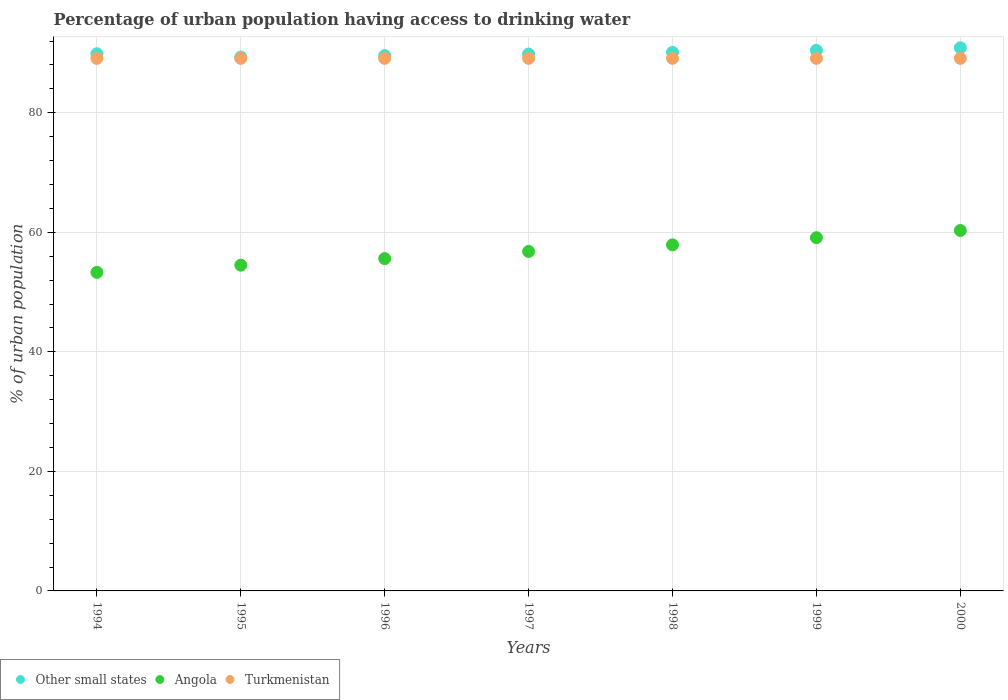Is the number of dotlines equal to the number of legend labels?
Give a very brief answer. Yes. What is the percentage of urban population having access to drinking water in Angola in 1998?
Keep it short and to the point. 57.9. Across all years, what is the maximum percentage of urban population having access to drinking water in Turkmenistan?
Offer a very short reply. 89.1. Across all years, what is the minimum percentage of urban population having access to drinking water in Other small states?
Provide a succinct answer. 89.31. In which year was the percentage of urban population having access to drinking water in Angola minimum?
Offer a very short reply. 1994. What is the total percentage of urban population having access to drinking water in Turkmenistan in the graph?
Make the answer very short. 623.7. What is the difference between the percentage of urban population having access to drinking water in Other small states in 1995 and that in 2000?
Offer a very short reply. -1.55. What is the difference between the percentage of urban population having access to drinking water in Angola in 1998 and the percentage of urban population having access to drinking water in Turkmenistan in 1996?
Give a very brief answer. -31.2. What is the average percentage of urban population having access to drinking water in Other small states per year?
Your response must be concise. 90. In the year 1998, what is the difference between the percentage of urban population having access to drinking water in Other small states and percentage of urban population having access to drinking water in Angola?
Give a very brief answer. 32.21. In how many years, is the percentage of urban population having access to drinking water in Turkmenistan greater than 60 %?
Your answer should be compact. 7. Is the percentage of urban population having access to drinking water in Angola in 1998 less than that in 2000?
Keep it short and to the point. Yes. Is the difference between the percentage of urban population having access to drinking water in Other small states in 1996 and 1998 greater than the difference between the percentage of urban population having access to drinking water in Angola in 1996 and 1998?
Your answer should be very brief. Yes. In how many years, is the percentage of urban population having access to drinking water in Angola greater than the average percentage of urban population having access to drinking water in Angola taken over all years?
Make the answer very short. 4. Is it the case that in every year, the sum of the percentage of urban population having access to drinking water in Other small states and percentage of urban population having access to drinking water in Turkmenistan  is greater than the percentage of urban population having access to drinking water in Angola?
Your response must be concise. Yes. Does the percentage of urban population having access to drinking water in Other small states monotonically increase over the years?
Keep it short and to the point. No. Is the percentage of urban population having access to drinking water in Angola strictly greater than the percentage of urban population having access to drinking water in Turkmenistan over the years?
Keep it short and to the point. No. How many years are there in the graph?
Ensure brevity in your answer.  7. Does the graph contain any zero values?
Your answer should be very brief. No. Does the graph contain grids?
Ensure brevity in your answer.  Yes. How many legend labels are there?
Keep it short and to the point. 3. How are the legend labels stacked?
Offer a terse response. Horizontal. What is the title of the graph?
Give a very brief answer. Percentage of urban population having access to drinking water. Does "Low & middle income" appear as one of the legend labels in the graph?
Your response must be concise. No. What is the label or title of the X-axis?
Provide a succinct answer. Years. What is the label or title of the Y-axis?
Your answer should be very brief. % of urban population. What is the % of urban population of Other small states in 1994?
Ensure brevity in your answer.  89.87. What is the % of urban population in Angola in 1994?
Your answer should be compact. 53.3. What is the % of urban population in Turkmenistan in 1994?
Make the answer very short. 89.1. What is the % of urban population in Other small states in 1995?
Keep it short and to the point. 89.31. What is the % of urban population in Angola in 1995?
Give a very brief answer. 54.5. What is the % of urban population in Turkmenistan in 1995?
Ensure brevity in your answer.  89.1. What is the % of urban population of Other small states in 1996?
Keep it short and to the point. 89.56. What is the % of urban population of Angola in 1996?
Ensure brevity in your answer.  55.6. What is the % of urban population of Turkmenistan in 1996?
Provide a succinct answer. 89.1. What is the % of urban population of Other small states in 1997?
Keep it short and to the point. 89.83. What is the % of urban population in Angola in 1997?
Keep it short and to the point. 56.8. What is the % of urban population in Turkmenistan in 1997?
Ensure brevity in your answer.  89.1. What is the % of urban population in Other small states in 1998?
Offer a very short reply. 90.11. What is the % of urban population of Angola in 1998?
Offer a terse response. 57.9. What is the % of urban population in Turkmenistan in 1998?
Provide a short and direct response. 89.1. What is the % of urban population in Other small states in 1999?
Make the answer very short. 90.45. What is the % of urban population in Angola in 1999?
Your answer should be very brief. 59.1. What is the % of urban population in Turkmenistan in 1999?
Offer a terse response. 89.1. What is the % of urban population of Other small states in 2000?
Your response must be concise. 90.87. What is the % of urban population in Angola in 2000?
Provide a short and direct response. 60.3. What is the % of urban population of Turkmenistan in 2000?
Ensure brevity in your answer.  89.1. Across all years, what is the maximum % of urban population in Other small states?
Provide a succinct answer. 90.87. Across all years, what is the maximum % of urban population of Angola?
Offer a very short reply. 60.3. Across all years, what is the maximum % of urban population of Turkmenistan?
Make the answer very short. 89.1. Across all years, what is the minimum % of urban population in Other small states?
Your answer should be very brief. 89.31. Across all years, what is the minimum % of urban population of Angola?
Your response must be concise. 53.3. Across all years, what is the minimum % of urban population of Turkmenistan?
Keep it short and to the point. 89.1. What is the total % of urban population in Other small states in the graph?
Give a very brief answer. 630. What is the total % of urban population of Angola in the graph?
Your answer should be very brief. 397.5. What is the total % of urban population in Turkmenistan in the graph?
Provide a succinct answer. 623.7. What is the difference between the % of urban population of Other small states in 1994 and that in 1995?
Offer a terse response. 0.56. What is the difference between the % of urban population in Turkmenistan in 1994 and that in 1995?
Keep it short and to the point. 0. What is the difference between the % of urban population of Other small states in 1994 and that in 1996?
Offer a very short reply. 0.31. What is the difference between the % of urban population of Angola in 1994 and that in 1996?
Ensure brevity in your answer.  -2.3. What is the difference between the % of urban population in Other small states in 1994 and that in 1997?
Offer a very short reply. 0.04. What is the difference between the % of urban population of Other small states in 1994 and that in 1998?
Provide a succinct answer. -0.24. What is the difference between the % of urban population in Turkmenistan in 1994 and that in 1998?
Provide a succinct answer. 0. What is the difference between the % of urban population of Other small states in 1994 and that in 1999?
Make the answer very short. -0.57. What is the difference between the % of urban population in Angola in 1994 and that in 1999?
Provide a succinct answer. -5.8. What is the difference between the % of urban population of Other small states in 1994 and that in 2000?
Give a very brief answer. -0.99. What is the difference between the % of urban population of Angola in 1994 and that in 2000?
Your answer should be very brief. -7. What is the difference between the % of urban population in Other small states in 1995 and that in 1996?
Your response must be concise. -0.25. What is the difference between the % of urban population of Turkmenistan in 1995 and that in 1996?
Offer a very short reply. 0. What is the difference between the % of urban population in Other small states in 1995 and that in 1997?
Offer a terse response. -0.51. What is the difference between the % of urban population in Turkmenistan in 1995 and that in 1997?
Ensure brevity in your answer.  0. What is the difference between the % of urban population in Other small states in 1995 and that in 1998?
Offer a terse response. -0.8. What is the difference between the % of urban population in Turkmenistan in 1995 and that in 1998?
Keep it short and to the point. 0. What is the difference between the % of urban population of Other small states in 1995 and that in 1999?
Offer a terse response. -1.13. What is the difference between the % of urban population of Other small states in 1995 and that in 2000?
Offer a terse response. -1.55. What is the difference between the % of urban population in Angola in 1995 and that in 2000?
Ensure brevity in your answer.  -5.8. What is the difference between the % of urban population in Other small states in 1996 and that in 1997?
Your answer should be compact. -0.27. What is the difference between the % of urban population in Angola in 1996 and that in 1997?
Your answer should be compact. -1.2. What is the difference between the % of urban population in Other small states in 1996 and that in 1998?
Provide a short and direct response. -0.55. What is the difference between the % of urban population in Turkmenistan in 1996 and that in 1998?
Your response must be concise. 0. What is the difference between the % of urban population of Other small states in 1996 and that in 1999?
Give a very brief answer. -0.89. What is the difference between the % of urban population of Other small states in 1996 and that in 2000?
Give a very brief answer. -1.31. What is the difference between the % of urban population in Angola in 1996 and that in 2000?
Ensure brevity in your answer.  -4.7. What is the difference between the % of urban population in Other small states in 1997 and that in 1998?
Provide a succinct answer. -0.28. What is the difference between the % of urban population of Other small states in 1997 and that in 1999?
Give a very brief answer. -0.62. What is the difference between the % of urban population of Angola in 1997 and that in 1999?
Keep it short and to the point. -2.3. What is the difference between the % of urban population in Other small states in 1997 and that in 2000?
Ensure brevity in your answer.  -1.04. What is the difference between the % of urban population in Other small states in 1998 and that in 1999?
Make the answer very short. -0.33. What is the difference between the % of urban population in Angola in 1998 and that in 1999?
Keep it short and to the point. -1.2. What is the difference between the % of urban population of Other small states in 1998 and that in 2000?
Provide a succinct answer. -0.75. What is the difference between the % of urban population in Turkmenistan in 1998 and that in 2000?
Your answer should be very brief. 0. What is the difference between the % of urban population of Other small states in 1999 and that in 2000?
Ensure brevity in your answer.  -0.42. What is the difference between the % of urban population of Turkmenistan in 1999 and that in 2000?
Keep it short and to the point. 0. What is the difference between the % of urban population in Other small states in 1994 and the % of urban population in Angola in 1995?
Give a very brief answer. 35.37. What is the difference between the % of urban population in Other small states in 1994 and the % of urban population in Turkmenistan in 1995?
Give a very brief answer. 0.77. What is the difference between the % of urban population of Angola in 1994 and the % of urban population of Turkmenistan in 1995?
Give a very brief answer. -35.8. What is the difference between the % of urban population of Other small states in 1994 and the % of urban population of Angola in 1996?
Your answer should be compact. 34.27. What is the difference between the % of urban population of Other small states in 1994 and the % of urban population of Turkmenistan in 1996?
Provide a short and direct response. 0.77. What is the difference between the % of urban population in Angola in 1994 and the % of urban population in Turkmenistan in 1996?
Offer a terse response. -35.8. What is the difference between the % of urban population in Other small states in 1994 and the % of urban population in Angola in 1997?
Provide a succinct answer. 33.07. What is the difference between the % of urban population in Other small states in 1994 and the % of urban population in Turkmenistan in 1997?
Your answer should be very brief. 0.77. What is the difference between the % of urban population of Angola in 1994 and the % of urban population of Turkmenistan in 1997?
Keep it short and to the point. -35.8. What is the difference between the % of urban population in Other small states in 1994 and the % of urban population in Angola in 1998?
Make the answer very short. 31.97. What is the difference between the % of urban population of Other small states in 1994 and the % of urban population of Turkmenistan in 1998?
Make the answer very short. 0.77. What is the difference between the % of urban population in Angola in 1994 and the % of urban population in Turkmenistan in 1998?
Ensure brevity in your answer.  -35.8. What is the difference between the % of urban population of Other small states in 1994 and the % of urban population of Angola in 1999?
Give a very brief answer. 30.77. What is the difference between the % of urban population in Other small states in 1994 and the % of urban population in Turkmenistan in 1999?
Your answer should be very brief. 0.77. What is the difference between the % of urban population in Angola in 1994 and the % of urban population in Turkmenistan in 1999?
Ensure brevity in your answer.  -35.8. What is the difference between the % of urban population in Other small states in 1994 and the % of urban population in Angola in 2000?
Your answer should be very brief. 29.57. What is the difference between the % of urban population in Other small states in 1994 and the % of urban population in Turkmenistan in 2000?
Give a very brief answer. 0.77. What is the difference between the % of urban population of Angola in 1994 and the % of urban population of Turkmenistan in 2000?
Ensure brevity in your answer.  -35.8. What is the difference between the % of urban population in Other small states in 1995 and the % of urban population in Angola in 1996?
Your response must be concise. 33.71. What is the difference between the % of urban population in Other small states in 1995 and the % of urban population in Turkmenistan in 1996?
Your answer should be very brief. 0.21. What is the difference between the % of urban population in Angola in 1995 and the % of urban population in Turkmenistan in 1996?
Give a very brief answer. -34.6. What is the difference between the % of urban population of Other small states in 1995 and the % of urban population of Angola in 1997?
Make the answer very short. 32.51. What is the difference between the % of urban population of Other small states in 1995 and the % of urban population of Turkmenistan in 1997?
Your answer should be very brief. 0.21. What is the difference between the % of urban population in Angola in 1995 and the % of urban population in Turkmenistan in 1997?
Make the answer very short. -34.6. What is the difference between the % of urban population of Other small states in 1995 and the % of urban population of Angola in 1998?
Your response must be concise. 31.41. What is the difference between the % of urban population in Other small states in 1995 and the % of urban population in Turkmenistan in 1998?
Provide a short and direct response. 0.21. What is the difference between the % of urban population of Angola in 1995 and the % of urban population of Turkmenistan in 1998?
Keep it short and to the point. -34.6. What is the difference between the % of urban population of Other small states in 1995 and the % of urban population of Angola in 1999?
Give a very brief answer. 30.21. What is the difference between the % of urban population of Other small states in 1995 and the % of urban population of Turkmenistan in 1999?
Provide a succinct answer. 0.21. What is the difference between the % of urban population in Angola in 1995 and the % of urban population in Turkmenistan in 1999?
Ensure brevity in your answer.  -34.6. What is the difference between the % of urban population in Other small states in 1995 and the % of urban population in Angola in 2000?
Make the answer very short. 29.01. What is the difference between the % of urban population of Other small states in 1995 and the % of urban population of Turkmenistan in 2000?
Give a very brief answer. 0.21. What is the difference between the % of urban population of Angola in 1995 and the % of urban population of Turkmenistan in 2000?
Your answer should be compact. -34.6. What is the difference between the % of urban population in Other small states in 1996 and the % of urban population in Angola in 1997?
Your response must be concise. 32.76. What is the difference between the % of urban population in Other small states in 1996 and the % of urban population in Turkmenistan in 1997?
Provide a short and direct response. 0.46. What is the difference between the % of urban population in Angola in 1996 and the % of urban population in Turkmenistan in 1997?
Your answer should be compact. -33.5. What is the difference between the % of urban population in Other small states in 1996 and the % of urban population in Angola in 1998?
Give a very brief answer. 31.66. What is the difference between the % of urban population in Other small states in 1996 and the % of urban population in Turkmenistan in 1998?
Your response must be concise. 0.46. What is the difference between the % of urban population in Angola in 1996 and the % of urban population in Turkmenistan in 1998?
Your response must be concise. -33.5. What is the difference between the % of urban population of Other small states in 1996 and the % of urban population of Angola in 1999?
Offer a very short reply. 30.46. What is the difference between the % of urban population of Other small states in 1996 and the % of urban population of Turkmenistan in 1999?
Offer a terse response. 0.46. What is the difference between the % of urban population of Angola in 1996 and the % of urban population of Turkmenistan in 1999?
Your answer should be compact. -33.5. What is the difference between the % of urban population in Other small states in 1996 and the % of urban population in Angola in 2000?
Make the answer very short. 29.26. What is the difference between the % of urban population in Other small states in 1996 and the % of urban population in Turkmenistan in 2000?
Ensure brevity in your answer.  0.46. What is the difference between the % of urban population of Angola in 1996 and the % of urban population of Turkmenistan in 2000?
Make the answer very short. -33.5. What is the difference between the % of urban population of Other small states in 1997 and the % of urban population of Angola in 1998?
Give a very brief answer. 31.93. What is the difference between the % of urban population in Other small states in 1997 and the % of urban population in Turkmenistan in 1998?
Offer a very short reply. 0.73. What is the difference between the % of urban population in Angola in 1997 and the % of urban population in Turkmenistan in 1998?
Provide a succinct answer. -32.3. What is the difference between the % of urban population of Other small states in 1997 and the % of urban population of Angola in 1999?
Make the answer very short. 30.73. What is the difference between the % of urban population in Other small states in 1997 and the % of urban population in Turkmenistan in 1999?
Make the answer very short. 0.73. What is the difference between the % of urban population in Angola in 1997 and the % of urban population in Turkmenistan in 1999?
Ensure brevity in your answer.  -32.3. What is the difference between the % of urban population of Other small states in 1997 and the % of urban population of Angola in 2000?
Your answer should be very brief. 29.53. What is the difference between the % of urban population of Other small states in 1997 and the % of urban population of Turkmenistan in 2000?
Ensure brevity in your answer.  0.73. What is the difference between the % of urban population in Angola in 1997 and the % of urban population in Turkmenistan in 2000?
Your answer should be very brief. -32.3. What is the difference between the % of urban population of Other small states in 1998 and the % of urban population of Angola in 1999?
Make the answer very short. 31.01. What is the difference between the % of urban population of Angola in 1998 and the % of urban population of Turkmenistan in 1999?
Give a very brief answer. -31.2. What is the difference between the % of urban population in Other small states in 1998 and the % of urban population in Angola in 2000?
Offer a very short reply. 29.81. What is the difference between the % of urban population in Other small states in 1998 and the % of urban population in Turkmenistan in 2000?
Give a very brief answer. 1.01. What is the difference between the % of urban population of Angola in 1998 and the % of urban population of Turkmenistan in 2000?
Your answer should be very brief. -31.2. What is the difference between the % of urban population of Other small states in 1999 and the % of urban population of Angola in 2000?
Give a very brief answer. 30.15. What is the difference between the % of urban population of Other small states in 1999 and the % of urban population of Turkmenistan in 2000?
Provide a short and direct response. 1.35. What is the average % of urban population in Other small states per year?
Your response must be concise. 90. What is the average % of urban population in Angola per year?
Ensure brevity in your answer.  56.79. What is the average % of urban population in Turkmenistan per year?
Your answer should be compact. 89.1. In the year 1994, what is the difference between the % of urban population in Other small states and % of urban population in Angola?
Provide a short and direct response. 36.57. In the year 1994, what is the difference between the % of urban population in Other small states and % of urban population in Turkmenistan?
Provide a short and direct response. 0.77. In the year 1994, what is the difference between the % of urban population of Angola and % of urban population of Turkmenistan?
Your answer should be compact. -35.8. In the year 1995, what is the difference between the % of urban population in Other small states and % of urban population in Angola?
Offer a very short reply. 34.81. In the year 1995, what is the difference between the % of urban population in Other small states and % of urban population in Turkmenistan?
Give a very brief answer. 0.21. In the year 1995, what is the difference between the % of urban population in Angola and % of urban population in Turkmenistan?
Offer a very short reply. -34.6. In the year 1996, what is the difference between the % of urban population in Other small states and % of urban population in Angola?
Provide a short and direct response. 33.96. In the year 1996, what is the difference between the % of urban population of Other small states and % of urban population of Turkmenistan?
Provide a succinct answer. 0.46. In the year 1996, what is the difference between the % of urban population in Angola and % of urban population in Turkmenistan?
Offer a terse response. -33.5. In the year 1997, what is the difference between the % of urban population of Other small states and % of urban population of Angola?
Your answer should be very brief. 33.03. In the year 1997, what is the difference between the % of urban population of Other small states and % of urban population of Turkmenistan?
Provide a short and direct response. 0.73. In the year 1997, what is the difference between the % of urban population in Angola and % of urban population in Turkmenistan?
Ensure brevity in your answer.  -32.3. In the year 1998, what is the difference between the % of urban population of Other small states and % of urban population of Angola?
Provide a succinct answer. 32.21. In the year 1998, what is the difference between the % of urban population in Other small states and % of urban population in Turkmenistan?
Provide a short and direct response. 1.01. In the year 1998, what is the difference between the % of urban population of Angola and % of urban population of Turkmenistan?
Your response must be concise. -31.2. In the year 1999, what is the difference between the % of urban population of Other small states and % of urban population of Angola?
Provide a succinct answer. 31.35. In the year 1999, what is the difference between the % of urban population in Other small states and % of urban population in Turkmenistan?
Offer a very short reply. 1.35. In the year 2000, what is the difference between the % of urban population of Other small states and % of urban population of Angola?
Provide a short and direct response. 30.57. In the year 2000, what is the difference between the % of urban population in Other small states and % of urban population in Turkmenistan?
Your answer should be compact. 1.77. In the year 2000, what is the difference between the % of urban population of Angola and % of urban population of Turkmenistan?
Keep it short and to the point. -28.8. What is the ratio of the % of urban population in Other small states in 1994 to that in 1995?
Give a very brief answer. 1.01. What is the ratio of the % of urban population of Angola in 1994 to that in 1995?
Your answer should be compact. 0.98. What is the ratio of the % of urban population of Turkmenistan in 1994 to that in 1995?
Provide a short and direct response. 1. What is the ratio of the % of urban population of Angola in 1994 to that in 1996?
Offer a very short reply. 0.96. What is the ratio of the % of urban population of Turkmenistan in 1994 to that in 1996?
Your response must be concise. 1. What is the ratio of the % of urban population in Other small states in 1994 to that in 1997?
Ensure brevity in your answer.  1. What is the ratio of the % of urban population in Angola in 1994 to that in 1997?
Your answer should be compact. 0.94. What is the ratio of the % of urban population of Angola in 1994 to that in 1998?
Ensure brevity in your answer.  0.92. What is the ratio of the % of urban population of Angola in 1994 to that in 1999?
Provide a short and direct response. 0.9. What is the ratio of the % of urban population of Other small states in 1994 to that in 2000?
Provide a succinct answer. 0.99. What is the ratio of the % of urban population in Angola in 1994 to that in 2000?
Your answer should be very brief. 0.88. What is the ratio of the % of urban population of Turkmenistan in 1994 to that in 2000?
Your response must be concise. 1. What is the ratio of the % of urban population in Other small states in 1995 to that in 1996?
Your response must be concise. 1. What is the ratio of the % of urban population in Angola in 1995 to that in 1996?
Make the answer very short. 0.98. What is the ratio of the % of urban population of Turkmenistan in 1995 to that in 1996?
Offer a terse response. 1. What is the ratio of the % of urban population in Other small states in 1995 to that in 1997?
Give a very brief answer. 0.99. What is the ratio of the % of urban population in Angola in 1995 to that in 1997?
Keep it short and to the point. 0.96. What is the ratio of the % of urban population in Angola in 1995 to that in 1998?
Provide a short and direct response. 0.94. What is the ratio of the % of urban population of Other small states in 1995 to that in 1999?
Provide a short and direct response. 0.99. What is the ratio of the % of urban population in Angola in 1995 to that in 1999?
Make the answer very short. 0.92. What is the ratio of the % of urban population of Turkmenistan in 1995 to that in 1999?
Your answer should be compact. 1. What is the ratio of the % of urban population of Other small states in 1995 to that in 2000?
Offer a terse response. 0.98. What is the ratio of the % of urban population of Angola in 1995 to that in 2000?
Ensure brevity in your answer.  0.9. What is the ratio of the % of urban population of Angola in 1996 to that in 1997?
Your answer should be compact. 0.98. What is the ratio of the % of urban population of Angola in 1996 to that in 1998?
Provide a short and direct response. 0.96. What is the ratio of the % of urban population in Other small states in 1996 to that in 1999?
Give a very brief answer. 0.99. What is the ratio of the % of urban population of Angola in 1996 to that in 1999?
Provide a succinct answer. 0.94. What is the ratio of the % of urban population of Turkmenistan in 1996 to that in 1999?
Ensure brevity in your answer.  1. What is the ratio of the % of urban population in Other small states in 1996 to that in 2000?
Give a very brief answer. 0.99. What is the ratio of the % of urban population of Angola in 1996 to that in 2000?
Your answer should be very brief. 0.92. What is the ratio of the % of urban population in Turkmenistan in 1997 to that in 1998?
Offer a very short reply. 1. What is the ratio of the % of urban population of Other small states in 1997 to that in 1999?
Make the answer very short. 0.99. What is the ratio of the % of urban population in Angola in 1997 to that in 1999?
Provide a short and direct response. 0.96. What is the ratio of the % of urban population of Turkmenistan in 1997 to that in 1999?
Give a very brief answer. 1. What is the ratio of the % of urban population in Angola in 1997 to that in 2000?
Give a very brief answer. 0.94. What is the ratio of the % of urban population of Angola in 1998 to that in 1999?
Your answer should be compact. 0.98. What is the ratio of the % of urban population in Other small states in 1998 to that in 2000?
Ensure brevity in your answer.  0.99. What is the ratio of the % of urban population in Angola in 1998 to that in 2000?
Give a very brief answer. 0.96. What is the ratio of the % of urban population of Angola in 1999 to that in 2000?
Ensure brevity in your answer.  0.98. What is the difference between the highest and the second highest % of urban population in Other small states?
Your answer should be compact. 0.42. What is the difference between the highest and the lowest % of urban population in Other small states?
Offer a very short reply. 1.55. What is the difference between the highest and the lowest % of urban population in Turkmenistan?
Your answer should be compact. 0. 